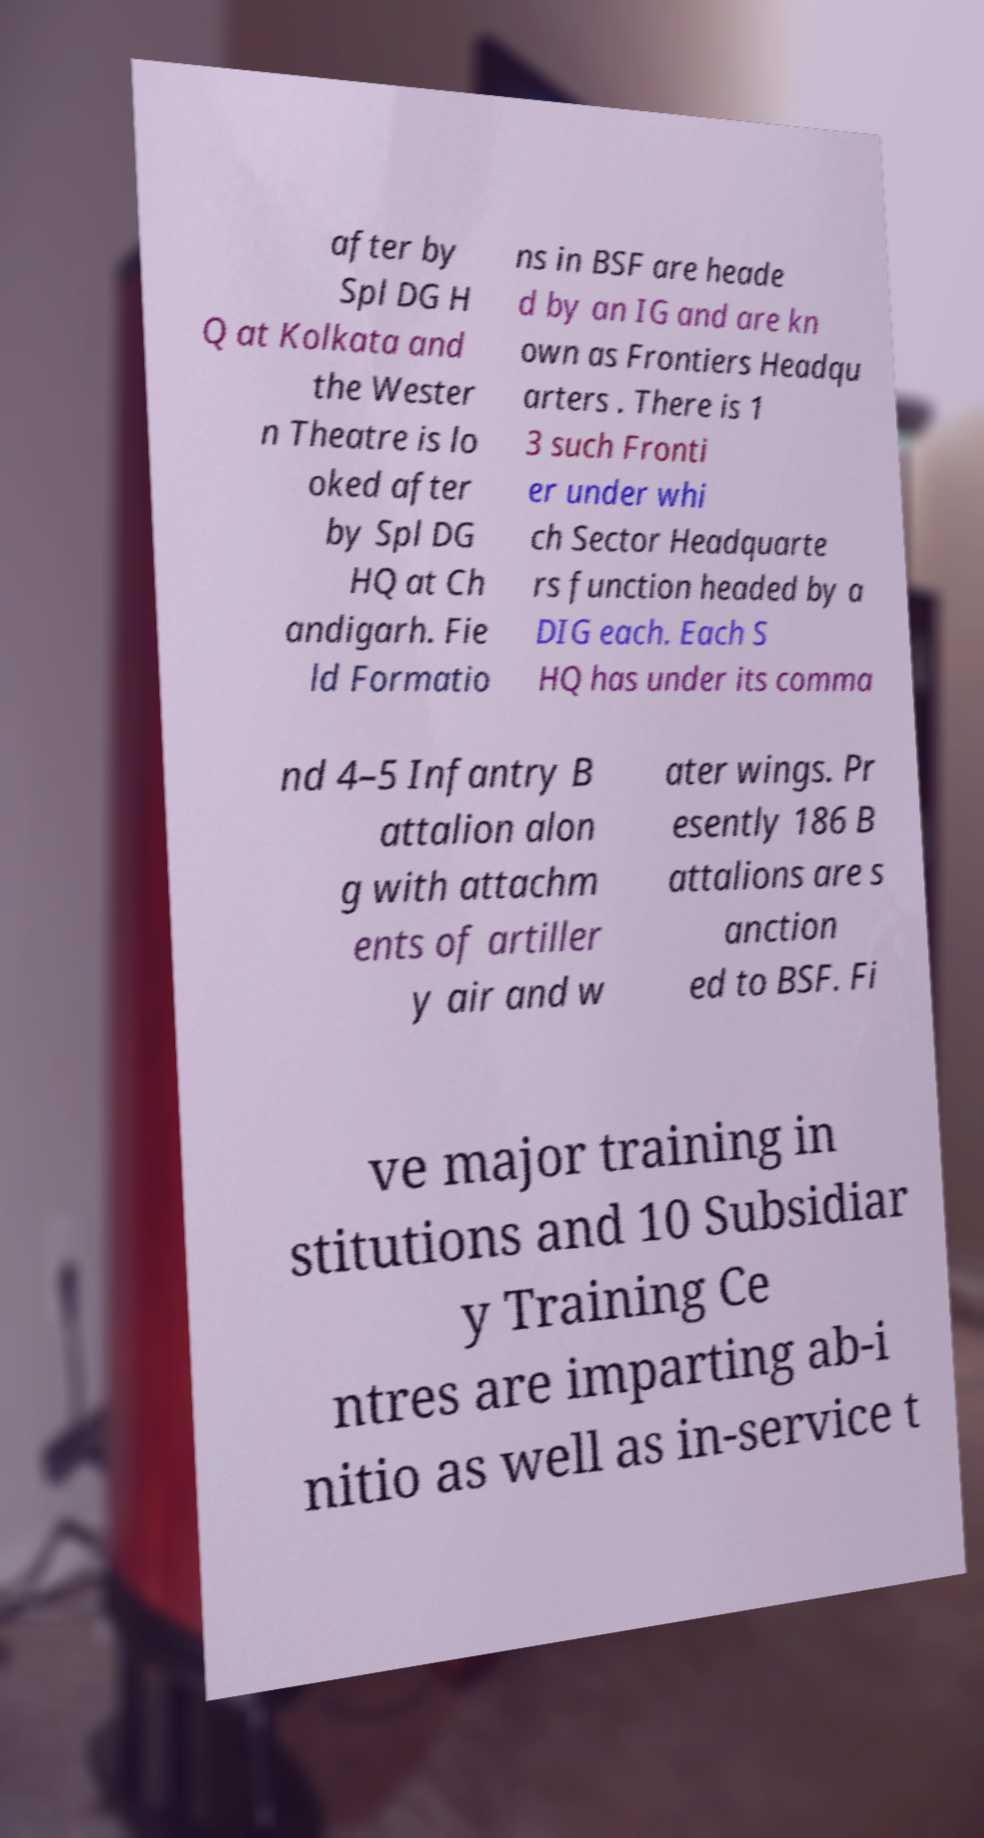Can you read and provide the text displayed in the image?This photo seems to have some interesting text. Can you extract and type it out for me? after by Spl DG H Q at Kolkata and the Wester n Theatre is lo oked after by Spl DG HQ at Ch andigarh. Fie ld Formatio ns in BSF are heade d by an IG and are kn own as Frontiers Headqu arters . There is 1 3 such Fronti er under whi ch Sector Headquarte rs function headed by a DIG each. Each S HQ has under its comma nd 4–5 Infantry B attalion alon g with attachm ents of artiller y air and w ater wings. Pr esently 186 B attalions are s anction ed to BSF. Fi ve major training in stitutions and 10 Subsidiar y Training Ce ntres are imparting ab-i nitio as well as in-service t 